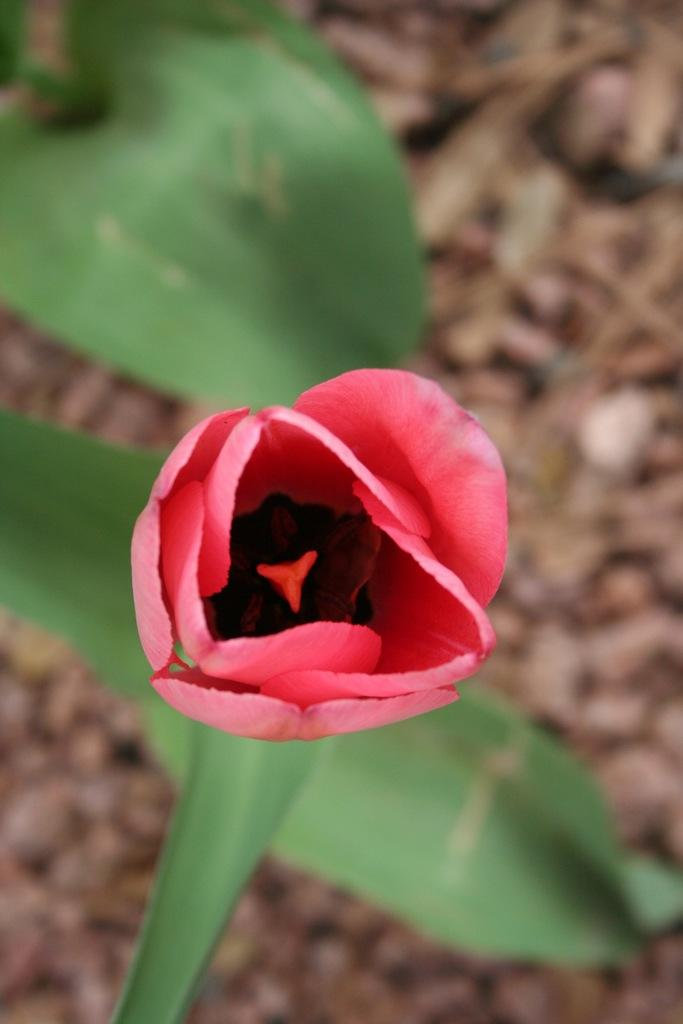What is the main subject in the foreground of the image? There is a flower in the foreground of the image. What can be seen in the background of the image? There are leaves in the background of the image. How is the background of the image depicted? The background is blurred. What type of fear does the flower have in the image? There is no indication of fear in the image, as flowers do not have emotions. 